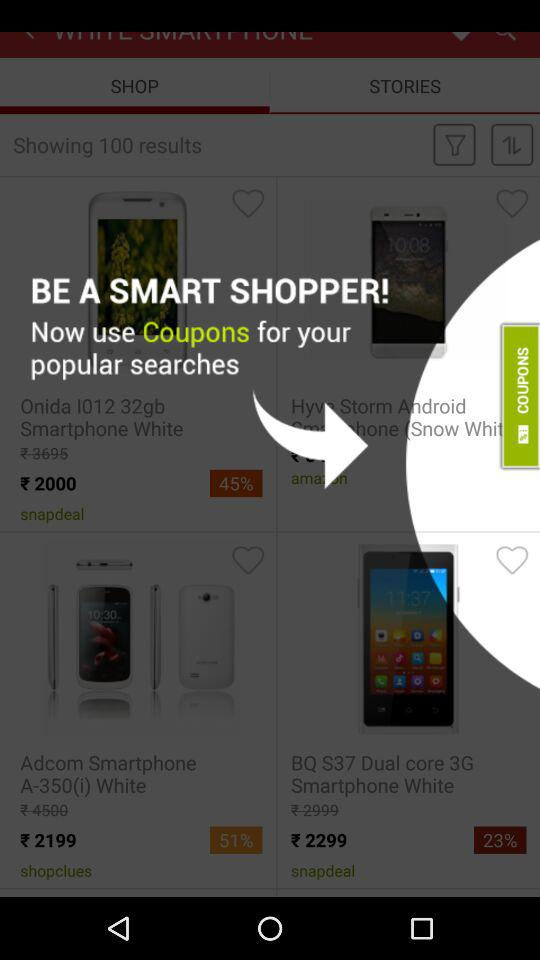How many smartphones have a price under 2500?
Answer the question using a single word or phrase. 3 